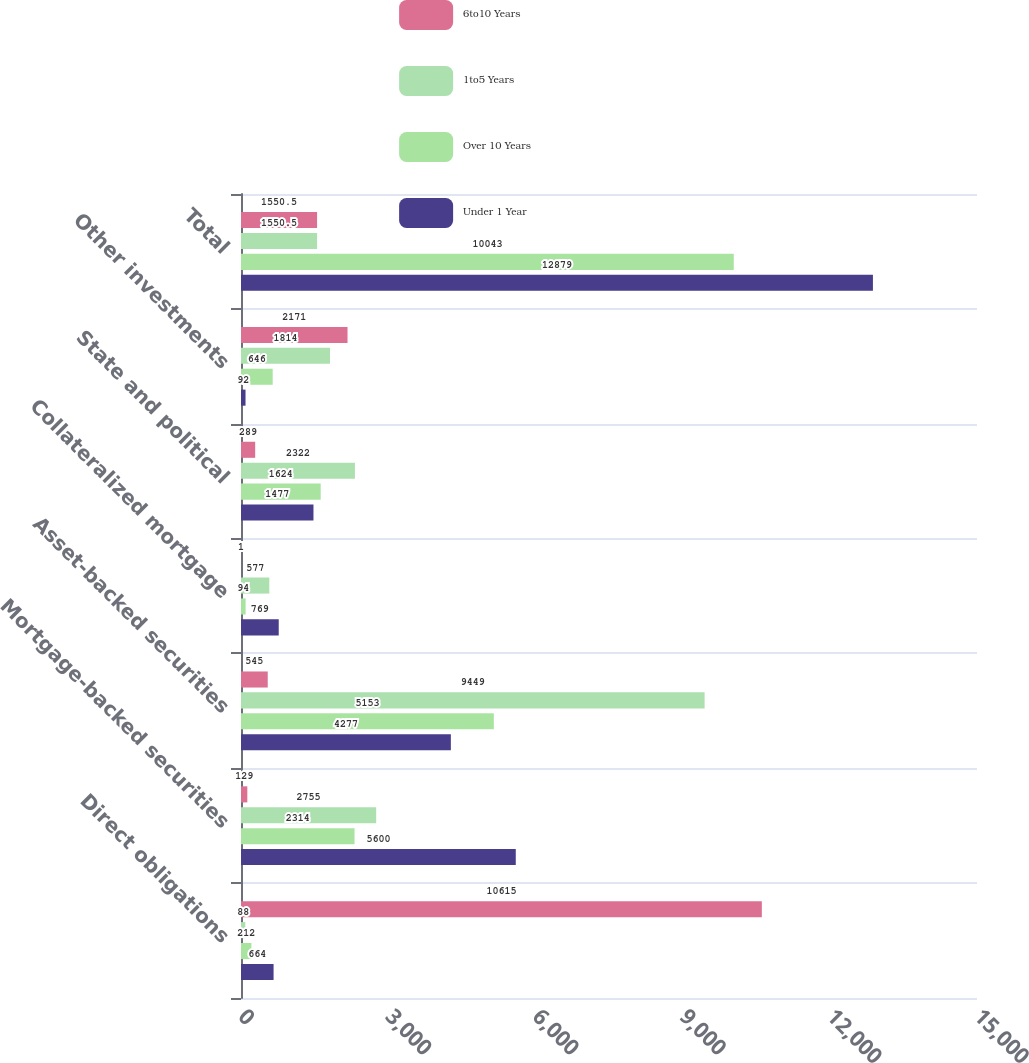Convert chart. <chart><loc_0><loc_0><loc_500><loc_500><stacked_bar_chart><ecel><fcel>Direct obligations<fcel>Mortgage-backed securities<fcel>Asset-backed securities<fcel>Collateralized mortgage<fcel>State and political<fcel>Other investments<fcel>Total<nl><fcel>6to10 Years<fcel>10615<fcel>129<fcel>545<fcel>1<fcel>289<fcel>2171<fcel>1550.5<nl><fcel>1to5 Years<fcel>88<fcel>2755<fcel>9449<fcel>577<fcel>2322<fcel>1814<fcel>1550.5<nl><fcel>Over 10 Years<fcel>212<fcel>2314<fcel>5153<fcel>94<fcel>1624<fcel>646<fcel>10043<nl><fcel>Under 1 Year<fcel>664<fcel>5600<fcel>4277<fcel>769<fcel>1477<fcel>92<fcel>12879<nl></chart> 